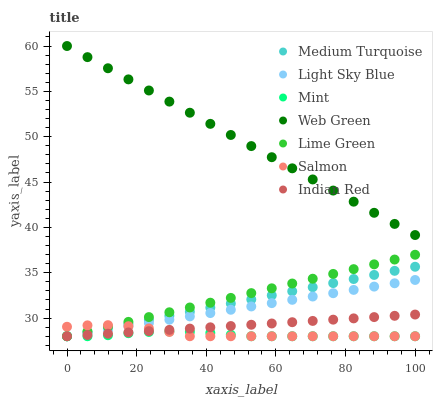Does Mint have the minimum area under the curve?
Answer yes or no. Yes. Does Web Green have the maximum area under the curve?
Answer yes or no. Yes. Does Salmon have the minimum area under the curve?
Answer yes or no. No. Does Salmon have the maximum area under the curve?
Answer yes or no. No. Is Indian Red the smoothest?
Answer yes or no. Yes. Is Salmon the roughest?
Answer yes or no. Yes. Is Mint the smoothest?
Answer yes or no. No. Is Mint the roughest?
Answer yes or no. No. Does Indian Red have the lowest value?
Answer yes or no. Yes. Does Web Green have the lowest value?
Answer yes or no. No. Does Web Green have the highest value?
Answer yes or no. Yes. Does Salmon have the highest value?
Answer yes or no. No. Is Medium Turquoise less than Web Green?
Answer yes or no. Yes. Is Web Green greater than Indian Red?
Answer yes or no. Yes. Does Mint intersect Light Sky Blue?
Answer yes or no. Yes. Is Mint less than Light Sky Blue?
Answer yes or no. No. Is Mint greater than Light Sky Blue?
Answer yes or no. No. Does Medium Turquoise intersect Web Green?
Answer yes or no. No. 